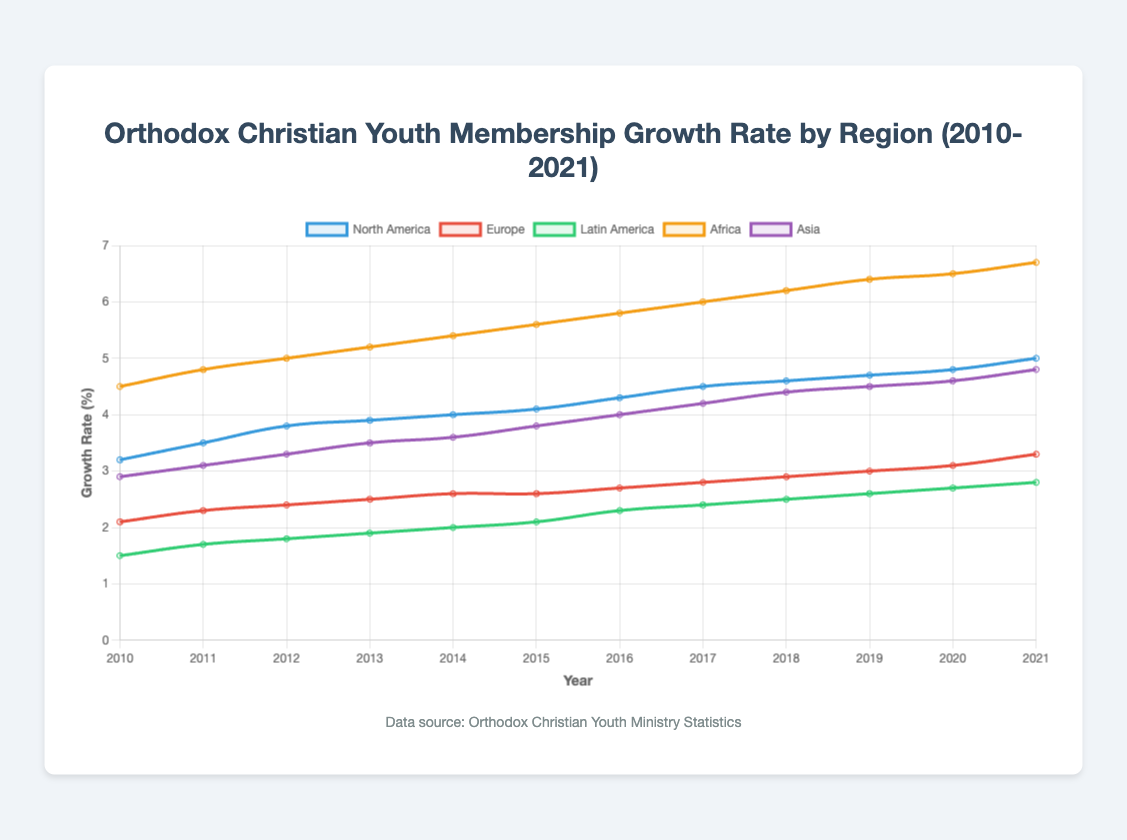What region has the highest growth rate in 2021? Look at the growth rates for each region in 2021 and compare them. Africa's growth rate is the highest at 6.7%.
Answer: Africa Which region showed the most consistent growth in youth membership between 2010 and 2021? To determine consistency, observe the smoothness and steadiness of the growth curve. Europe's growth rate curve shows a steady and consistent upward trend without abrupt changes.
Answer: Europe What is the difference in growth rate between Africa and Europe in 2021? Look at the growth rate for Africa (6.7%) and Europe (3.3%) in 2021. Subtract the two values: 6.7% - 3.3% = 3.4%.
Answer: 3.4% Which region experienced the fastest increase in growth rate from 2010 to 2021? Calculate the change in growth rate for each region from 2010 to 2021. Africa had an increase from 4.5% to 6.7%, which is the fastest increase of 2.2%.
Answer: Africa How did the growth rate in North America change between 2015 and 2020? Look at the growth rates for North America in 2015 (4.1%) and 2020 (4.8%). Subtract the 2015 rate from the 2020 rate: 4.8% - 4.1% = 0.7%.
Answer: Increased by 0.7% Compare the growth rates of North America and Asia in 2013. Which region had a higher rate? Look at the growth rates for North America (3.9%) and Asia (3.5%) in 2013 and compare them. North America's rate is higher.
Answer: North America By how much did the growth rate in Latin America increase from 2010 to 2021? Look at the growth rates for Latin America in 2010 (1.5%) and 2021 (2.8%). Subtract the 2010 rate from the 2021 rate: 2.8% - 1.5% = 1.3%.
Answer: 1.3% What is the median growth rate for Europe's youth membership from 2010 to 2021? Order the growth rates for Europe from 2010 to 2021: [2.1, 2.3, 2.4, 2.5, 2.6, 2.6, 2.7, 2.8, 2.9, 3.0, 3.1, 3.3]. The median is the average of the middle two values (2.6 and 2.6), which is 2.6%.
Answer: 2.6% Which region had the lowest growth rate in 2010 and what was it? Compare the growth rates of all regions in 2010. Latin America had the lowest growth rate at 1.5%.
Answer: Latin America, 1.5% How does the growth trend of Asia compare to that of Africa from 2010 to 2021? Observe the growth trends for Asia and Africa. Both show increasing trends, but Asia starts lower and ends at 4.8%, while Africa starts higher and ends at 6.7%. Africa has consistently higher growth rates throughout the period.
Answer: Africa has higher and faster growth 